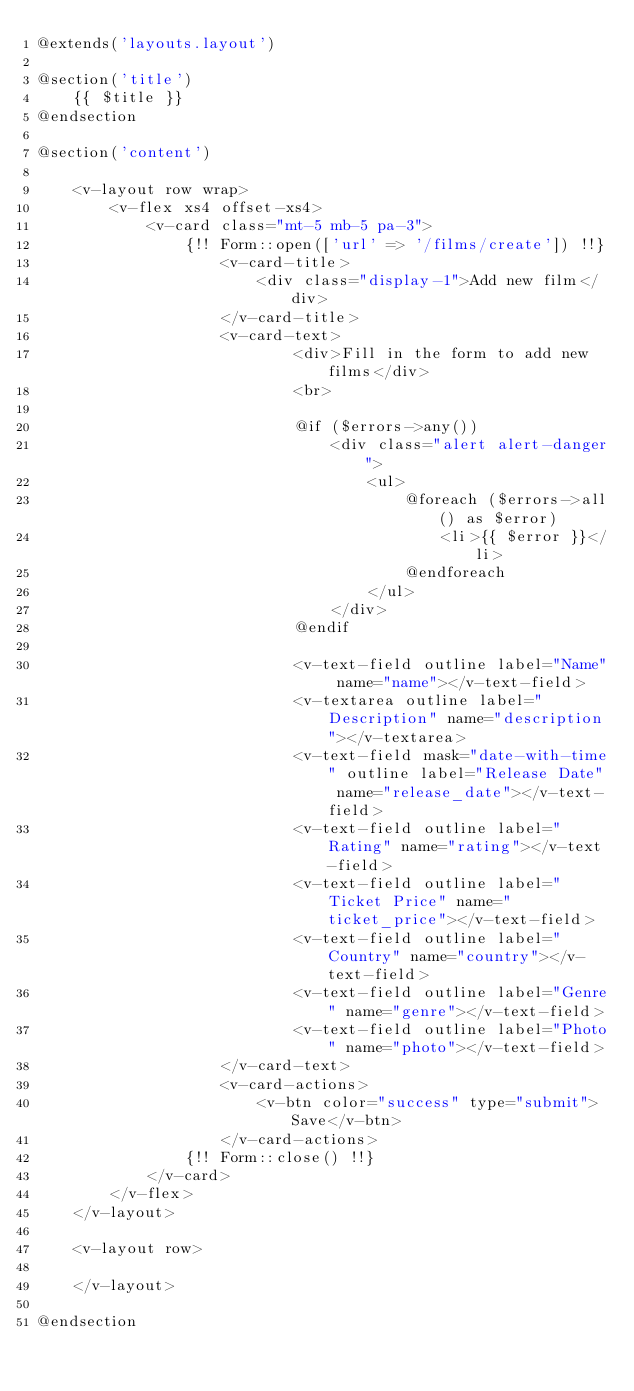<code> <loc_0><loc_0><loc_500><loc_500><_PHP_>@extends('layouts.layout')

@section('title')
    {{ $title }}
@endsection

@section('content')

    <v-layout row wrap>
        <v-flex xs4 offset-xs4>
            <v-card class="mt-5 mb-5 pa-3">
                {!! Form::open(['url' => '/films/create']) !!}
                    <v-card-title>
                        <div class="display-1">Add new film</div>
                    </v-card-title>
                    <v-card-text>
                            <div>Fill in the form to add new films</div>
                            <br>

                            @if ($errors->any())
                                <div class="alert alert-danger">
                                    <ul>
                                        @foreach ($errors->all() as $error)
                                            <li>{{ $error }}</li>
                                        @endforeach
                                    </ul>
                                </div>
                            @endif

                            <v-text-field outline label="Name" name="name"></v-text-field>
                            <v-textarea outline label="Description" name="description"></v-textarea>
                            <v-text-field mask="date-with-time" outline label="Release Date" name="release_date"></v-text-field>
                            <v-text-field outline label="Rating" name="rating"></v-text-field>
                            <v-text-field outline label="Ticket Price" name="ticket_price"></v-text-field>
                            <v-text-field outline label="Country" name="country"></v-text-field>
                            <v-text-field outline label="Genre" name="genre"></v-text-field>
                            <v-text-field outline label="Photo" name="photo"></v-text-field>
                    </v-card-text>
                    <v-card-actions>
                        <v-btn color="success" type="submit">Save</v-btn>
                    </v-card-actions>
                {!! Form::close() !!}
            </v-card>
        </v-flex>
    </v-layout>

    <v-layout row>

    </v-layout>

@endsection</code> 